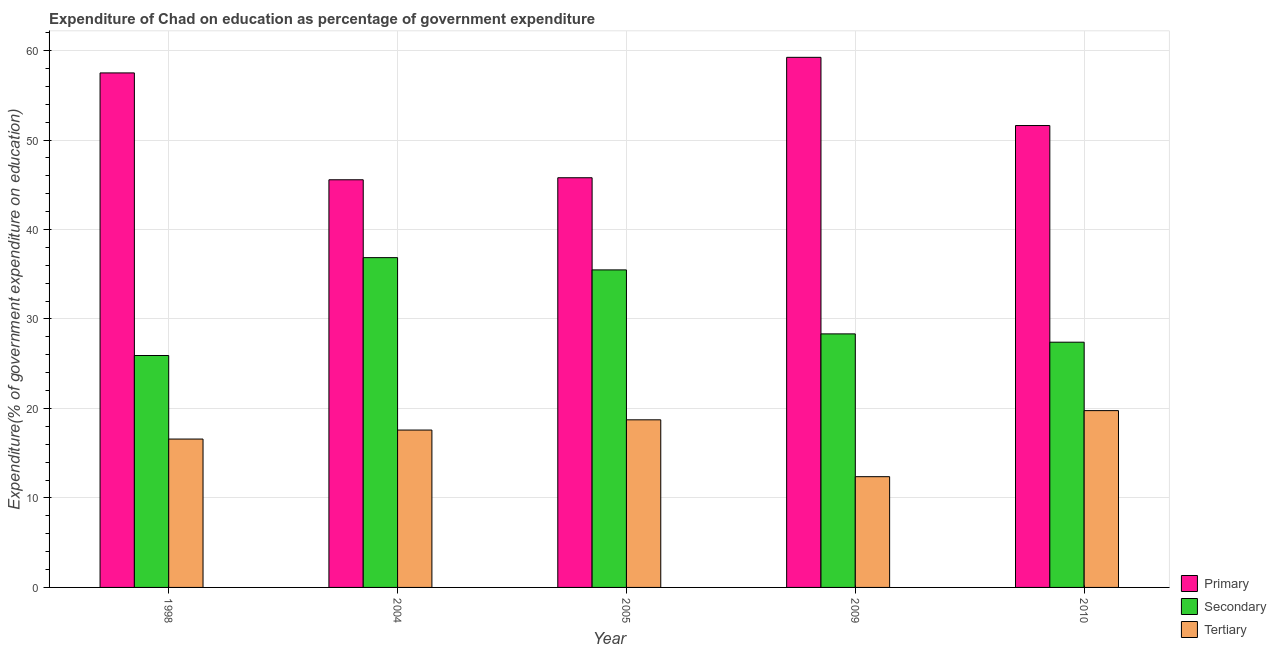How many different coloured bars are there?
Ensure brevity in your answer.  3. How many groups of bars are there?
Provide a short and direct response. 5. Are the number of bars per tick equal to the number of legend labels?
Offer a terse response. Yes. Are the number of bars on each tick of the X-axis equal?
Offer a terse response. Yes. In how many cases, is the number of bars for a given year not equal to the number of legend labels?
Give a very brief answer. 0. What is the expenditure on secondary education in 2009?
Ensure brevity in your answer.  28.33. Across all years, what is the maximum expenditure on secondary education?
Give a very brief answer. 36.86. Across all years, what is the minimum expenditure on tertiary education?
Give a very brief answer. 12.38. In which year was the expenditure on secondary education maximum?
Offer a terse response. 2004. In which year was the expenditure on secondary education minimum?
Your answer should be very brief. 1998. What is the total expenditure on primary education in the graph?
Offer a very short reply. 259.7. What is the difference between the expenditure on tertiary education in 2004 and that in 2009?
Offer a terse response. 5.21. What is the difference between the expenditure on secondary education in 2010 and the expenditure on tertiary education in 2005?
Your answer should be very brief. -8.08. What is the average expenditure on secondary education per year?
Your answer should be very brief. 30.8. In the year 2005, what is the difference between the expenditure on tertiary education and expenditure on secondary education?
Give a very brief answer. 0. What is the ratio of the expenditure on tertiary education in 2005 to that in 2010?
Offer a terse response. 0.95. What is the difference between the highest and the second highest expenditure on tertiary education?
Keep it short and to the point. 1.03. What is the difference between the highest and the lowest expenditure on primary education?
Give a very brief answer. 13.68. Is the sum of the expenditure on secondary education in 2009 and 2010 greater than the maximum expenditure on primary education across all years?
Give a very brief answer. Yes. What does the 2nd bar from the left in 2010 represents?
Make the answer very short. Secondary. What does the 1st bar from the right in 1998 represents?
Keep it short and to the point. Tertiary. How many bars are there?
Make the answer very short. 15. What is the difference between two consecutive major ticks on the Y-axis?
Keep it short and to the point. 10. Does the graph contain grids?
Your response must be concise. Yes. How many legend labels are there?
Make the answer very short. 3. How are the legend labels stacked?
Your answer should be compact. Vertical. What is the title of the graph?
Provide a short and direct response. Expenditure of Chad on education as percentage of government expenditure. Does "Argument" appear as one of the legend labels in the graph?
Your answer should be compact. No. What is the label or title of the Y-axis?
Offer a terse response. Expenditure(% of government expenditure on education). What is the Expenditure(% of government expenditure on education) in Primary in 1998?
Offer a very short reply. 57.5. What is the Expenditure(% of government expenditure on education) in Secondary in 1998?
Provide a short and direct response. 25.92. What is the Expenditure(% of government expenditure on education) of Tertiary in 1998?
Keep it short and to the point. 16.58. What is the Expenditure(% of government expenditure on education) of Primary in 2004?
Offer a very short reply. 45.56. What is the Expenditure(% of government expenditure on education) in Secondary in 2004?
Keep it short and to the point. 36.86. What is the Expenditure(% of government expenditure on education) of Tertiary in 2004?
Offer a very short reply. 17.59. What is the Expenditure(% of government expenditure on education) in Primary in 2005?
Ensure brevity in your answer.  45.78. What is the Expenditure(% of government expenditure on education) of Secondary in 2005?
Provide a succinct answer. 35.48. What is the Expenditure(% of government expenditure on education) in Tertiary in 2005?
Make the answer very short. 18.73. What is the Expenditure(% of government expenditure on education) of Primary in 2009?
Provide a short and direct response. 59.24. What is the Expenditure(% of government expenditure on education) in Secondary in 2009?
Ensure brevity in your answer.  28.33. What is the Expenditure(% of government expenditure on education) in Tertiary in 2009?
Your answer should be very brief. 12.38. What is the Expenditure(% of government expenditure on education) of Primary in 2010?
Offer a terse response. 51.62. What is the Expenditure(% of government expenditure on education) of Secondary in 2010?
Keep it short and to the point. 27.41. What is the Expenditure(% of government expenditure on education) of Tertiary in 2010?
Offer a very short reply. 19.76. Across all years, what is the maximum Expenditure(% of government expenditure on education) of Primary?
Offer a terse response. 59.24. Across all years, what is the maximum Expenditure(% of government expenditure on education) of Secondary?
Offer a terse response. 36.86. Across all years, what is the maximum Expenditure(% of government expenditure on education) of Tertiary?
Offer a very short reply. 19.76. Across all years, what is the minimum Expenditure(% of government expenditure on education) of Primary?
Give a very brief answer. 45.56. Across all years, what is the minimum Expenditure(% of government expenditure on education) of Secondary?
Ensure brevity in your answer.  25.92. Across all years, what is the minimum Expenditure(% of government expenditure on education) of Tertiary?
Keep it short and to the point. 12.38. What is the total Expenditure(% of government expenditure on education) in Primary in the graph?
Your answer should be compact. 259.7. What is the total Expenditure(% of government expenditure on education) in Secondary in the graph?
Provide a short and direct response. 154. What is the total Expenditure(% of government expenditure on education) of Tertiary in the graph?
Give a very brief answer. 85.03. What is the difference between the Expenditure(% of government expenditure on education) of Primary in 1998 and that in 2004?
Keep it short and to the point. 11.94. What is the difference between the Expenditure(% of government expenditure on education) in Secondary in 1998 and that in 2004?
Provide a succinct answer. -10.94. What is the difference between the Expenditure(% of government expenditure on education) in Tertiary in 1998 and that in 2004?
Offer a very short reply. -1. What is the difference between the Expenditure(% of government expenditure on education) in Primary in 1998 and that in 2005?
Provide a succinct answer. 11.71. What is the difference between the Expenditure(% of government expenditure on education) in Secondary in 1998 and that in 2005?
Provide a succinct answer. -9.57. What is the difference between the Expenditure(% of government expenditure on education) in Tertiary in 1998 and that in 2005?
Ensure brevity in your answer.  -2.15. What is the difference between the Expenditure(% of government expenditure on education) in Primary in 1998 and that in 2009?
Offer a very short reply. -1.74. What is the difference between the Expenditure(% of government expenditure on education) in Secondary in 1998 and that in 2009?
Make the answer very short. -2.42. What is the difference between the Expenditure(% of government expenditure on education) in Tertiary in 1998 and that in 2009?
Your response must be concise. 4.21. What is the difference between the Expenditure(% of government expenditure on education) in Primary in 1998 and that in 2010?
Offer a very short reply. 5.88. What is the difference between the Expenditure(% of government expenditure on education) of Secondary in 1998 and that in 2010?
Provide a succinct answer. -1.49. What is the difference between the Expenditure(% of government expenditure on education) of Tertiary in 1998 and that in 2010?
Keep it short and to the point. -3.18. What is the difference between the Expenditure(% of government expenditure on education) in Primary in 2004 and that in 2005?
Keep it short and to the point. -0.23. What is the difference between the Expenditure(% of government expenditure on education) of Secondary in 2004 and that in 2005?
Your answer should be compact. 1.37. What is the difference between the Expenditure(% of government expenditure on education) of Tertiary in 2004 and that in 2005?
Make the answer very short. -1.14. What is the difference between the Expenditure(% of government expenditure on education) of Primary in 2004 and that in 2009?
Your response must be concise. -13.68. What is the difference between the Expenditure(% of government expenditure on education) in Secondary in 2004 and that in 2009?
Offer a terse response. 8.52. What is the difference between the Expenditure(% of government expenditure on education) of Tertiary in 2004 and that in 2009?
Offer a terse response. 5.21. What is the difference between the Expenditure(% of government expenditure on education) of Primary in 2004 and that in 2010?
Give a very brief answer. -6.06. What is the difference between the Expenditure(% of government expenditure on education) of Secondary in 2004 and that in 2010?
Make the answer very short. 9.45. What is the difference between the Expenditure(% of government expenditure on education) of Tertiary in 2004 and that in 2010?
Your answer should be very brief. -2.17. What is the difference between the Expenditure(% of government expenditure on education) of Primary in 2005 and that in 2009?
Your answer should be compact. -13.46. What is the difference between the Expenditure(% of government expenditure on education) of Secondary in 2005 and that in 2009?
Keep it short and to the point. 7.15. What is the difference between the Expenditure(% of government expenditure on education) of Tertiary in 2005 and that in 2009?
Your response must be concise. 6.35. What is the difference between the Expenditure(% of government expenditure on education) in Primary in 2005 and that in 2010?
Make the answer very short. -5.83. What is the difference between the Expenditure(% of government expenditure on education) of Secondary in 2005 and that in 2010?
Keep it short and to the point. 8.08. What is the difference between the Expenditure(% of government expenditure on education) in Tertiary in 2005 and that in 2010?
Your answer should be very brief. -1.03. What is the difference between the Expenditure(% of government expenditure on education) in Primary in 2009 and that in 2010?
Your answer should be very brief. 7.62. What is the difference between the Expenditure(% of government expenditure on education) of Secondary in 2009 and that in 2010?
Offer a terse response. 0.93. What is the difference between the Expenditure(% of government expenditure on education) in Tertiary in 2009 and that in 2010?
Make the answer very short. -7.38. What is the difference between the Expenditure(% of government expenditure on education) in Primary in 1998 and the Expenditure(% of government expenditure on education) in Secondary in 2004?
Provide a succinct answer. 20.64. What is the difference between the Expenditure(% of government expenditure on education) of Primary in 1998 and the Expenditure(% of government expenditure on education) of Tertiary in 2004?
Give a very brief answer. 39.91. What is the difference between the Expenditure(% of government expenditure on education) of Secondary in 1998 and the Expenditure(% of government expenditure on education) of Tertiary in 2004?
Keep it short and to the point. 8.33. What is the difference between the Expenditure(% of government expenditure on education) in Primary in 1998 and the Expenditure(% of government expenditure on education) in Secondary in 2005?
Keep it short and to the point. 22.01. What is the difference between the Expenditure(% of government expenditure on education) in Primary in 1998 and the Expenditure(% of government expenditure on education) in Tertiary in 2005?
Your response must be concise. 38.77. What is the difference between the Expenditure(% of government expenditure on education) in Secondary in 1998 and the Expenditure(% of government expenditure on education) in Tertiary in 2005?
Your response must be concise. 7.19. What is the difference between the Expenditure(% of government expenditure on education) of Primary in 1998 and the Expenditure(% of government expenditure on education) of Secondary in 2009?
Offer a terse response. 29.17. What is the difference between the Expenditure(% of government expenditure on education) in Primary in 1998 and the Expenditure(% of government expenditure on education) in Tertiary in 2009?
Keep it short and to the point. 45.12. What is the difference between the Expenditure(% of government expenditure on education) of Secondary in 1998 and the Expenditure(% of government expenditure on education) of Tertiary in 2009?
Your answer should be very brief. 13.54. What is the difference between the Expenditure(% of government expenditure on education) in Primary in 1998 and the Expenditure(% of government expenditure on education) in Secondary in 2010?
Give a very brief answer. 30.09. What is the difference between the Expenditure(% of government expenditure on education) in Primary in 1998 and the Expenditure(% of government expenditure on education) in Tertiary in 2010?
Provide a succinct answer. 37.74. What is the difference between the Expenditure(% of government expenditure on education) in Secondary in 1998 and the Expenditure(% of government expenditure on education) in Tertiary in 2010?
Offer a terse response. 6.16. What is the difference between the Expenditure(% of government expenditure on education) in Primary in 2004 and the Expenditure(% of government expenditure on education) in Secondary in 2005?
Provide a succinct answer. 10.07. What is the difference between the Expenditure(% of government expenditure on education) in Primary in 2004 and the Expenditure(% of government expenditure on education) in Tertiary in 2005?
Your answer should be very brief. 26.83. What is the difference between the Expenditure(% of government expenditure on education) of Secondary in 2004 and the Expenditure(% of government expenditure on education) of Tertiary in 2005?
Provide a succinct answer. 18.13. What is the difference between the Expenditure(% of government expenditure on education) of Primary in 2004 and the Expenditure(% of government expenditure on education) of Secondary in 2009?
Keep it short and to the point. 17.22. What is the difference between the Expenditure(% of government expenditure on education) of Primary in 2004 and the Expenditure(% of government expenditure on education) of Tertiary in 2009?
Give a very brief answer. 33.18. What is the difference between the Expenditure(% of government expenditure on education) in Secondary in 2004 and the Expenditure(% of government expenditure on education) in Tertiary in 2009?
Ensure brevity in your answer.  24.48. What is the difference between the Expenditure(% of government expenditure on education) in Primary in 2004 and the Expenditure(% of government expenditure on education) in Secondary in 2010?
Provide a succinct answer. 18.15. What is the difference between the Expenditure(% of government expenditure on education) in Primary in 2004 and the Expenditure(% of government expenditure on education) in Tertiary in 2010?
Ensure brevity in your answer.  25.8. What is the difference between the Expenditure(% of government expenditure on education) in Secondary in 2004 and the Expenditure(% of government expenditure on education) in Tertiary in 2010?
Provide a succinct answer. 17.1. What is the difference between the Expenditure(% of government expenditure on education) of Primary in 2005 and the Expenditure(% of government expenditure on education) of Secondary in 2009?
Provide a succinct answer. 17.45. What is the difference between the Expenditure(% of government expenditure on education) of Primary in 2005 and the Expenditure(% of government expenditure on education) of Tertiary in 2009?
Your answer should be compact. 33.41. What is the difference between the Expenditure(% of government expenditure on education) of Secondary in 2005 and the Expenditure(% of government expenditure on education) of Tertiary in 2009?
Offer a terse response. 23.11. What is the difference between the Expenditure(% of government expenditure on education) of Primary in 2005 and the Expenditure(% of government expenditure on education) of Secondary in 2010?
Your response must be concise. 18.38. What is the difference between the Expenditure(% of government expenditure on education) of Primary in 2005 and the Expenditure(% of government expenditure on education) of Tertiary in 2010?
Provide a short and direct response. 26.03. What is the difference between the Expenditure(% of government expenditure on education) of Secondary in 2005 and the Expenditure(% of government expenditure on education) of Tertiary in 2010?
Offer a terse response. 15.73. What is the difference between the Expenditure(% of government expenditure on education) in Primary in 2009 and the Expenditure(% of government expenditure on education) in Secondary in 2010?
Ensure brevity in your answer.  31.84. What is the difference between the Expenditure(% of government expenditure on education) in Primary in 2009 and the Expenditure(% of government expenditure on education) in Tertiary in 2010?
Provide a short and direct response. 39.48. What is the difference between the Expenditure(% of government expenditure on education) in Secondary in 2009 and the Expenditure(% of government expenditure on education) in Tertiary in 2010?
Give a very brief answer. 8.58. What is the average Expenditure(% of government expenditure on education) in Primary per year?
Provide a short and direct response. 51.94. What is the average Expenditure(% of government expenditure on education) of Secondary per year?
Make the answer very short. 30.8. What is the average Expenditure(% of government expenditure on education) in Tertiary per year?
Give a very brief answer. 17.01. In the year 1998, what is the difference between the Expenditure(% of government expenditure on education) of Primary and Expenditure(% of government expenditure on education) of Secondary?
Provide a short and direct response. 31.58. In the year 1998, what is the difference between the Expenditure(% of government expenditure on education) in Primary and Expenditure(% of government expenditure on education) in Tertiary?
Keep it short and to the point. 40.92. In the year 1998, what is the difference between the Expenditure(% of government expenditure on education) in Secondary and Expenditure(% of government expenditure on education) in Tertiary?
Keep it short and to the point. 9.34. In the year 2004, what is the difference between the Expenditure(% of government expenditure on education) in Primary and Expenditure(% of government expenditure on education) in Secondary?
Your answer should be very brief. 8.7. In the year 2004, what is the difference between the Expenditure(% of government expenditure on education) in Primary and Expenditure(% of government expenditure on education) in Tertiary?
Your response must be concise. 27.97. In the year 2004, what is the difference between the Expenditure(% of government expenditure on education) in Secondary and Expenditure(% of government expenditure on education) in Tertiary?
Your answer should be compact. 19.27. In the year 2005, what is the difference between the Expenditure(% of government expenditure on education) of Primary and Expenditure(% of government expenditure on education) of Secondary?
Ensure brevity in your answer.  10.3. In the year 2005, what is the difference between the Expenditure(% of government expenditure on education) of Primary and Expenditure(% of government expenditure on education) of Tertiary?
Keep it short and to the point. 27.05. In the year 2005, what is the difference between the Expenditure(% of government expenditure on education) of Secondary and Expenditure(% of government expenditure on education) of Tertiary?
Offer a terse response. 16.75. In the year 2009, what is the difference between the Expenditure(% of government expenditure on education) of Primary and Expenditure(% of government expenditure on education) of Secondary?
Offer a very short reply. 30.91. In the year 2009, what is the difference between the Expenditure(% of government expenditure on education) in Primary and Expenditure(% of government expenditure on education) in Tertiary?
Offer a terse response. 46.86. In the year 2009, what is the difference between the Expenditure(% of government expenditure on education) in Secondary and Expenditure(% of government expenditure on education) in Tertiary?
Provide a succinct answer. 15.96. In the year 2010, what is the difference between the Expenditure(% of government expenditure on education) in Primary and Expenditure(% of government expenditure on education) in Secondary?
Keep it short and to the point. 24.21. In the year 2010, what is the difference between the Expenditure(% of government expenditure on education) in Primary and Expenditure(% of government expenditure on education) in Tertiary?
Provide a succinct answer. 31.86. In the year 2010, what is the difference between the Expenditure(% of government expenditure on education) of Secondary and Expenditure(% of government expenditure on education) of Tertiary?
Keep it short and to the point. 7.65. What is the ratio of the Expenditure(% of government expenditure on education) of Primary in 1998 to that in 2004?
Give a very brief answer. 1.26. What is the ratio of the Expenditure(% of government expenditure on education) of Secondary in 1998 to that in 2004?
Give a very brief answer. 0.7. What is the ratio of the Expenditure(% of government expenditure on education) of Tertiary in 1998 to that in 2004?
Your answer should be compact. 0.94. What is the ratio of the Expenditure(% of government expenditure on education) of Primary in 1998 to that in 2005?
Offer a terse response. 1.26. What is the ratio of the Expenditure(% of government expenditure on education) of Secondary in 1998 to that in 2005?
Keep it short and to the point. 0.73. What is the ratio of the Expenditure(% of government expenditure on education) of Tertiary in 1998 to that in 2005?
Your response must be concise. 0.89. What is the ratio of the Expenditure(% of government expenditure on education) in Primary in 1998 to that in 2009?
Give a very brief answer. 0.97. What is the ratio of the Expenditure(% of government expenditure on education) of Secondary in 1998 to that in 2009?
Your answer should be very brief. 0.91. What is the ratio of the Expenditure(% of government expenditure on education) in Tertiary in 1998 to that in 2009?
Provide a succinct answer. 1.34. What is the ratio of the Expenditure(% of government expenditure on education) in Primary in 1998 to that in 2010?
Your answer should be compact. 1.11. What is the ratio of the Expenditure(% of government expenditure on education) in Secondary in 1998 to that in 2010?
Your response must be concise. 0.95. What is the ratio of the Expenditure(% of government expenditure on education) of Tertiary in 1998 to that in 2010?
Ensure brevity in your answer.  0.84. What is the ratio of the Expenditure(% of government expenditure on education) of Primary in 2004 to that in 2005?
Give a very brief answer. 0.99. What is the ratio of the Expenditure(% of government expenditure on education) in Secondary in 2004 to that in 2005?
Provide a succinct answer. 1.04. What is the ratio of the Expenditure(% of government expenditure on education) in Tertiary in 2004 to that in 2005?
Offer a terse response. 0.94. What is the ratio of the Expenditure(% of government expenditure on education) in Primary in 2004 to that in 2009?
Ensure brevity in your answer.  0.77. What is the ratio of the Expenditure(% of government expenditure on education) in Secondary in 2004 to that in 2009?
Provide a short and direct response. 1.3. What is the ratio of the Expenditure(% of government expenditure on education) of Tertiary in 2004 to that in 2009?
Make the answer very short. 1.42. What is the ratio of the Expenditure(% of government expenditure on education) of Primary in 2004 to that in 2010?
Offer a terse response. 0.88. What is the ratio of the Expenditure(% of government expenditure on education) in Secondary in 2004 to that in 2010?
Provide a short and direct response. 1.34. What is the ratio of the Expenditure(% of government expenditure on education) of Tertiary in 2004 to that in 2010?
Give a very brief answer. 0.89. What is the ratio of the Expenditure(% of government expenditure on education) of Primary in 2005 to that in 2009?
Offer a very short reply. 0.77. What is the ratio of the Expenditure(% of government expenditure on education) of Secondary in 2005 to that in 2009?
Provide a short and direct response. 1.25. What is the ratio of the Expenditure(% of government expenditure on education) in Tertiary in 2005 to that in 2009?
Ensure brevity in your answer.  1.51. What is the ratio of the Expenditure(% of government expenditure on education) in Primary in 2005 to that in 2010?
Make the answer very short. 0.89. What is the ratio of the Expenditure(% of government expenditure on education) of Secondary in 2005 to that in 2010?
Ensure brevity in your answer.  1.29. What is the ratio of the Expenditure(% of government expenditure on education) of Tertiary in 2005 to that in 2010?
Ensure brevity in your answer.  0.95. What is the ratio of the Expenditure(% of government expenditure on education) of Primary in 2009 to that in 2010?
Keep it short and to the point. 1.15. What is the ratio of the Expenditure(% of government expenditure on education) in Secondary in 2009 to that in 2010?
Your answer should be compact. 1.03. What is the ratio of the Expenditure(% of government expenditure on education) in Tertiary in 2009 to that in 2010?
Your response must be concise. 0.63. What is the difference between the highest and the second highest Expenditure(% of government expenditure on education) in Primary?
Provide a succinct answer. 1.74. What is the difference between the highest and the second highest Expenditure(% of government expenditure on education) in Secondary?
Offer a very short reply. 1.37. What is the difference between the highest and the second highest Expenditure(% of government expenditure on education) in Tertiary?
Provide a succinct answer. 1.03. What is the difference between the highest and the lowest Expenditure(% of government expenditure on education) in Primary?
Ensure brevity in your answer.  13.68. What is the difference between the highest and the lowest Expenditure(% of government expenditure on education) of Secondary?
Provide a short and direct response. 10.94. What is the difference between the highest and the lowest Expenditure(% of government expenditure on education) of Tertiary?
Make the answer very short. 7.38. 